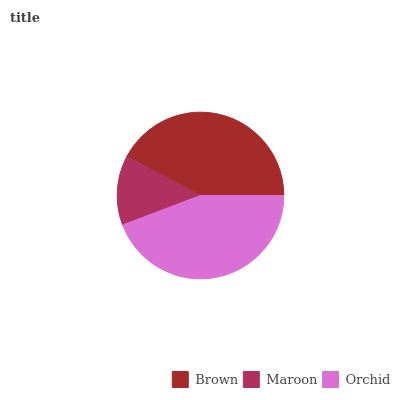Is Maroon the minimum?
Answer yes or no. Yes. Is Orchid the maximum?
Answer yes or no. Yes. Is Orchid the minimum?
Answer yes or no. No. Is Maroon the maximum?
Answer yes or no. No. Is Orchid greater than Maroon?
Answer yes or no. Yes. Is Maroon less than Orchid?
Answer yes or no. Yes. Is Maroon greater than Orchid?
Answer yes or no. No. Is Orchid less than Maroon?
Answer yes or no. No. Is Brown the high median?
Answer yes or no. Yes. Is Brown the low median?
Answer yes or no. Yes. Is Maroon the high median?
Answer yes or no. No. Is Maroon the low median?
Answer yes or no. No. 